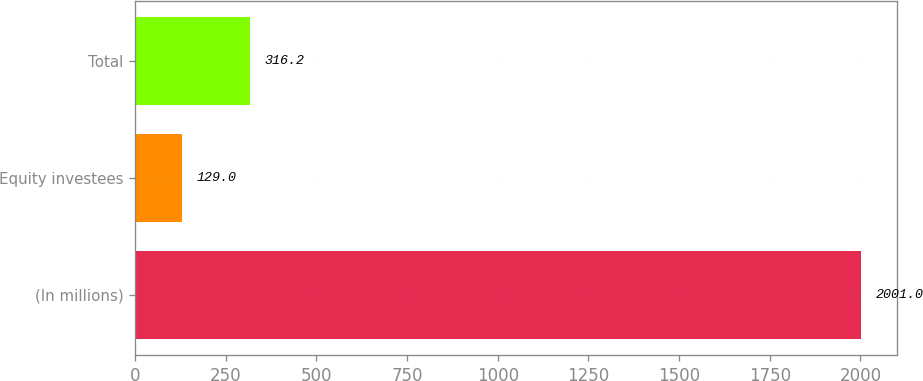<chart> <loc_0><loc_0><loc_500><loc_500><bar_chart><fcel>(In millions)<fcel>Equity investees<fcel>Total<nl><fcel>2001<fcel>129<fcel>316.2<nl></chart> 